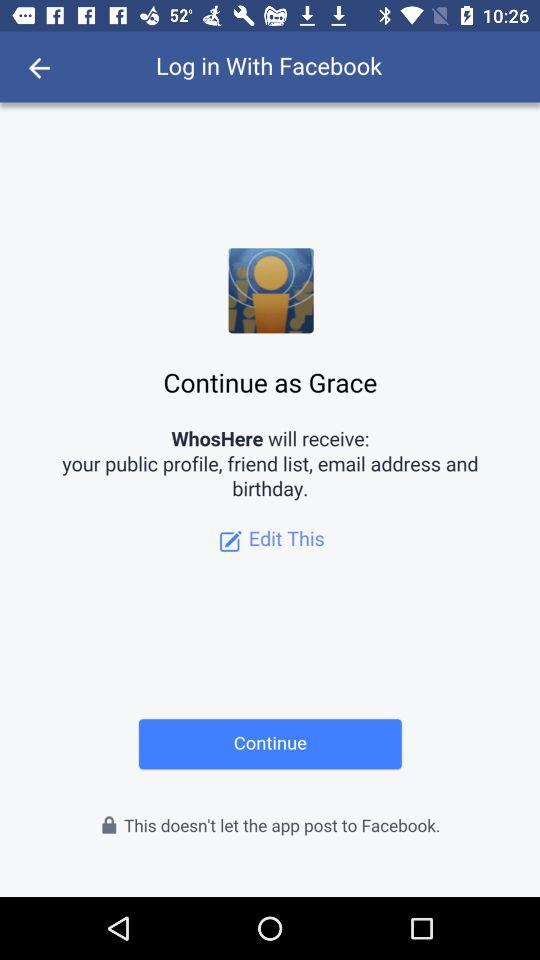Through what application can we log in? You can log in through "Facebook". 